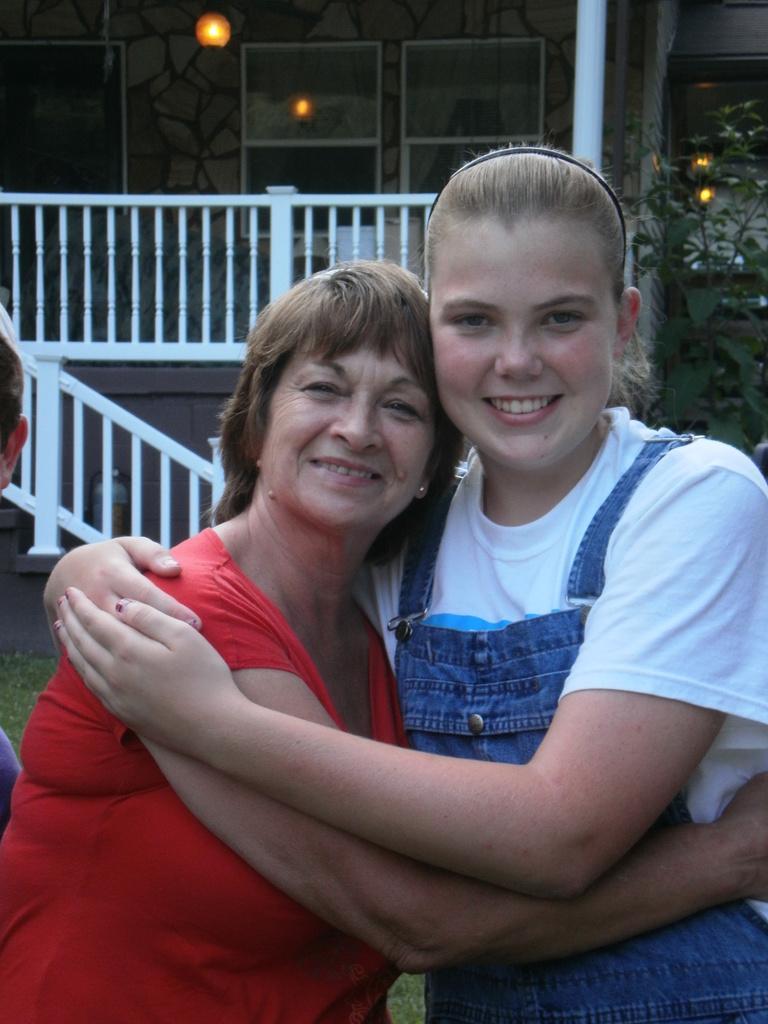In one or two sentences, can you explain what this image depicts? In this image there are two women standing towards the bottom of the image, there is a person's head and ear visible towards the left of the image, there is a plant towards the right of the image, there is a wooden object towards the left of the image, there is a pole towards the top of the image, there is a light towards the top of the image, there is a wall, there are windows, there is grass towards the left of the image. 